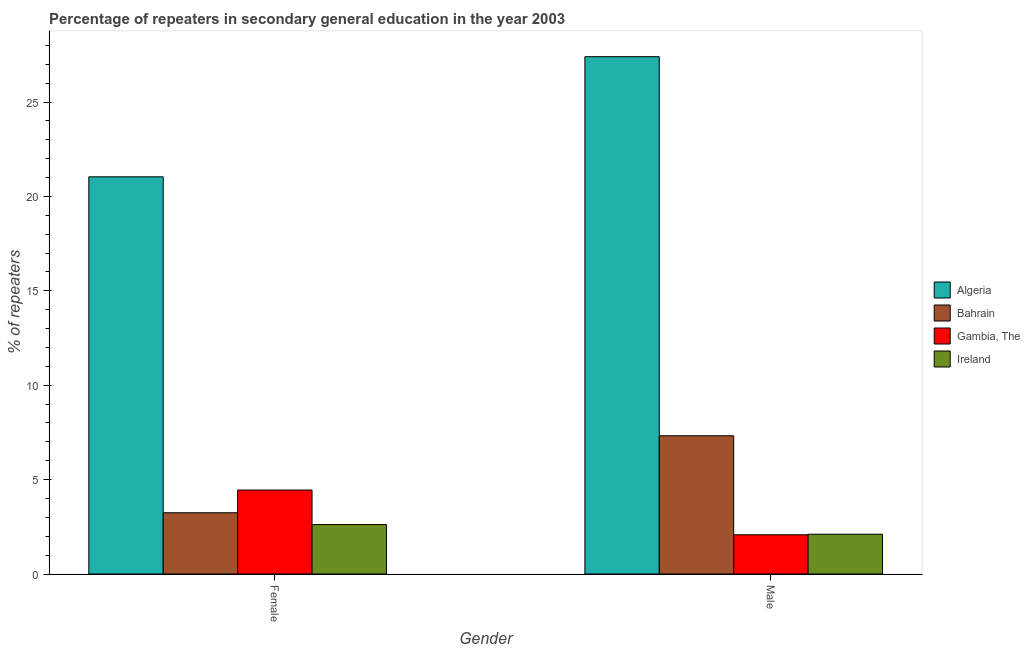How many groups of bars are there?
Your answer should be compact. 2. Are the number of bars per tick equal to the number of legend labels?
Make the answer very short. Yes. Are the number of bars on each tick of the X-axis equal?
Give a very brief answer. Yes. How many bars are there on the 2nd tick from the left?
Give a very brief answer. 4. What is the percentage of male repeaters in Gambia, The?
Keep it short and to the point. 2.08. Across all countries, what is the maximum percentage of female repeaters?
Keep it short and to the point. 21.04. Across all countries, what is the minimum percentage of male repeaters?
Ensure brevity in your answer.  2.08. In which country was the percentage of male repeaters maximum?
Your answer should be compact. Algeria. In which country was the percentage of female repeaters minimum?
Keep it short and to the point. Ireland. What is the total percentage of male repeaters in the graph?
Provide a short and direct response. 38.91. What is the difference between the percentage of female repeaters in Gambia, The and that in Bahrain?
Provide a succinct answer. 1.2. What is the difference between the percentage of female repeaters in Bahrain and the percentage of male repeaters in Ireland?
Make the answer very short. 1.14. What is the average percentage of female repeaters per country?
Offer a terse response. 7.84. What is the difference between the percentage of male repeaters and percentage of female repeaters in Ireland?
Offer a very short reply. -0.51. What is the ratio of the percentage of male repeaters in Gambia, The to that in Bahrain?
Provide a short and direct response. 0.28. Is the percentage of female repeaters in Gambia, The less than that in Algeria?
Ensure brevity in your answer.  Yes. What does the 2nd bar from the left in Female represents?
Offer a very short reply. Bahrain. What does the 1st bar from the right in Male represents?
Ensure brevity in your answer.  Ireland. How many bars are there?
Ensure brevity in your answer.  8. Are all the bars in the graph horizontal?
Give a very brief answer. No. Are the values on the major ticks of Y-axis written in scientific E-notation?
Your answer should be compact. No. Does the graph contain grids?
Keep it short and to the point. No. Where does the legend appear in the graph?
Ensure brevity in your answer.  Center right. How many legend labels are there?
Provide a short and direct response. 4. How are the legend labels stacked?
Your answer should be compact. Vertical. What is the title of the graph?
Ensure brevity in your answer.  Percentage of repeaters in secondary general education in the year 2003. What is the label or title of the Y-axis?
Give a very brief answer. % of repeaters. What is the % of repeaters in Algeria in Female?
Offer a very short reply. 21.04. What is the % of repeaters of Bahrain in Female?
Provide a short and direct response. 3.24. What is the % of repeaters of Gambia, The in Female?
Provide a succinct answer. 4.45. What is the % of repeaters in Ireland in Female?
Offer a terse response. 2.62. What is the % of repeaters in Algeria in Male?
Your answer should be very brief. 27.4. What is the % of repeaters in Bahrain in Male?
Offer a very short reply. 7.32. What is the % of repeaters of Gambia, The in Male?
Make the answer very short. 2.08. What is the % of repeaters of Ireland in Male?
Make the answer very short. 2.11. Across all Gender, what is the maximum % of repeaters in Algeria?
Keep it short and to the point. 27.4. Across all Gender, what is the maximum % of repeaters of Bahrain?
Provide a succinct answer. 7.32. Across all Gender, what is the maximum % of repeaters of Gambia, The?
Give a very brief answer. 4.45. Across all Gender, what is the maximum % of repeaters in Ireland?
Keep it short and to the point. 2.62. Across all Gender, what is the minimum % of repeaters of Algeria?
Make the answer very short. 21.04. Across all Gender, what is the minimum % of repeaters of Bahrain?
Make the answer very short. 3.24. Across all Gender, what is the minimum % of repeaters of Gambia, The?
Keep it short and to the point. 2.08. Across all Gender, what is the minimum % of repeaters of Ireland?
Your response must be concise. 2.11. What is the total % of repeaters in Algeria in the graph?
Your answer should be very brief. 48.44. What is the total % of repeaters of Bahrain in the graph?
Ensure brevity in your answer.  10.57. What is the total % of repeaters in Gambia, The in the graph?
Offer a very short reply. 6.53. What is the total % of repeaters of Ireland in the graph?
Your answer should be very brief. 4.72. What is the difference between the % of repeaters in Algeria in Female and that in Male?
Make the answer very short. -6.36. What is the difference between the % of repeaters in Bahrain in Female and that in Male?
Your response must be concise. -4.08. What is the difference between the % of repeaters of Gambia, The in Female and that in Male?
Your response must be concise. 2.37. What is the difference between the % of repeaters in Ireland in Female and that in Male?
Your answer should be very brief. 0.51. What is the difference between the % of repeaters of Algeria in Female and the % of repeaters of Bahrain in Male?
Your answer should be compact. 13.72. What is the difference between the % of repeaters in Algeria in Female and the % of repeaters in Gambia, The in Male?
Your response must be concise. 18.96. What is the difference between the % of repeaters of Algeria in Female and the % of repeaters of Ireland in Male?
Provide a succinct answer. 18.93. What is the difference between the % of repeaters of Bahrain in Female and the % of repeaters of Gambia, The in Male?
Offer a terse response. 1.17. What is the difference between the % of repeaters of Bahrain in Female and the % of repeaters of Ireland in Male?
Provide a short and direct response. 1.14. What is the difference between the % of repeaters in Gambia, The in Female and the % of repeaters in Ireland in Male?
Offer a very short reply. 2.34. What is the average % of repeaters in Algeria per Gender?
Provide a short and direct response. 24.22. What is the average % of repeaters of Bahrain per Gender?
Your answer should be very brief. 5.28. What is the average % of repeaters of Gambia, The per Gender?
Provide a succinct answer. 3.26. What is the average % of repeaters in Ireland per Gender?
Make the answer very short. 2.36. What is the difference between the % of repeaters of Algeria and % of repeaters of Bahrain in Female?
Give a very brief answer. 17.79. What is the difference between the % of repeaters of Algeria and % of repeaters of Gambia, The in Female?
Provide a short and direct response. 16.59. What is the difference between the % of repeaters in Algeria and % of repeaters in Ireland in Female?
Give a very brief answer. 18.42. What is the difference between the % of repeaters in Bahrain and % of repeaters in Gambia, The in Female?
Give a very brief answer. -1.2. What is the difference between the % of repeaters of Bahrain and % of repeaters of Ireland in Female?
Offer a terse response. 0.63. What is the difference between the % of repeaters in Gambia, The and % of repeaters in Ireland in Female?
Provide a short and direct response. 1.83. What is the difference between the % of repeaters in Algeria and % of repeaters in Bahrain in Male?
Your response must be concise. 20.08. What is the difference between the % of repeaters of Algeria and % of repeaters of Gambia, The in Male?
Offer a very short reply. 25.32. What is the difference between the % of repeaters of Algeria and % of repeaters of Ireland in Male?
Provide a short and direct response. 25.29. What is the difference between the % of repeaters of Bahrain and % of repeaters of Gambia, The in Male?
Offer a very short reply. 5.24. What is the difference between the % of repeaters in Bahrain and % of repeaters in Ireland in Male?
Provide a short and direct response. 5.21. What is the difference between the % of repeaters in Gambia, The and % of repeaters in Ireland in Male?
Your answer should be very brief. -0.03. What is the ratio of the % of repeaters in Algeria in Female to that in Male?
Your answer should be compact. 0.77. What is the ratio of the % of repeaters in Bahrain in Female to that in Male?
Offer a very short reply. 0.44. What is the ratio of the % of repeaters in Gambia, The in Female to that in Male?
Ensure brevity in your answer.  2.14. What is the ratio of the % of repeaters in Ireland in Female to that in Male?
Your answer should be very brief. 1.24. What is the difference between the highest and the second highest % of repeaters of Algeria?
Make the answer very short. 6.36. What is the difference between the highest and the second highest % of repeaters in Bahrain?
Offer a terse response. 4.08. What is the difference between the highest and the second highest % of repeaters of Gambia, The?
Provide a short and direct response. 2.37. What is the difference between the highest and the second highest % of repeaters in Ireland?
Keep it short and to the point. 0.51. What is the difference between the highest and the lowest % of repeaters in Algeria?
Offer a terse response. 6.36. What is the difference between the highest and the lowest % of repeaters of Bahrain?
Provide a succinct answer. 4.08. What is the difference between the highest and the lowest % of repeaters of Gambia, The?
Offer a terse response. 2.37. What is the difference between the highest and the lowest % of repeaters of Ireland?
Your answer should be very brief. 0.51. 